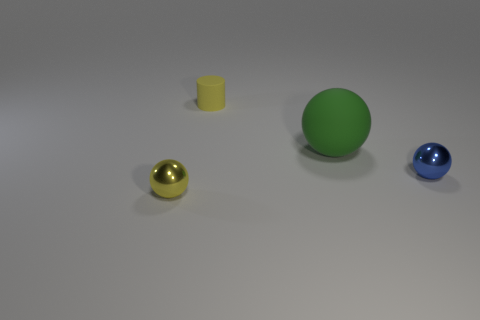There is a green ball that is the same material as the yellow cylinder; what is its size?
Ensure brevity in your answer.  Large. Is the number of small yellow matte cylinders less than the number of small things?
Give a very brief answer. Yes. What material is the yellow object in front of the metallic sphere right of the tiny yellow object in front of the blue object?
Your answer should be compact. Metal. Are the ball that is behind the blue shiny thing and the sphere that is to the right of the big sphere made of the same material?
Your answer should be very brief. No. There is a sphere that is both left of the small blue object and to the right of the tiny yellow metallic sphere; what size is it?
Make the answer very short. Large. What is the material of the blue sphere that is the same size as the yellow rubber cylinder?
Keep it short and to the point. Metal. How many tiny things are behind the tiny metal sphere that is right of the shiny object on the left side of the small cylinder?
Keep it short and to the point. 1. There is a small metallic ball that is to the right of the tiny yellow shiny thing; is its color the same as the large matte object that is right of the yellow metal ball?
Offer a very short reply. No. There is a tiny thing that is in front of the yellow rubber thing and to the left of the big ball; what is its color?
Make the answer very short. Yellow. What number of metallic objects have the same size as the yellow cylinder?
Keep it short and to the point. 2. 